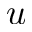Convert formula to latex. <formula><loc_0><loc_0><loc_500><loc_500>u</formula> 